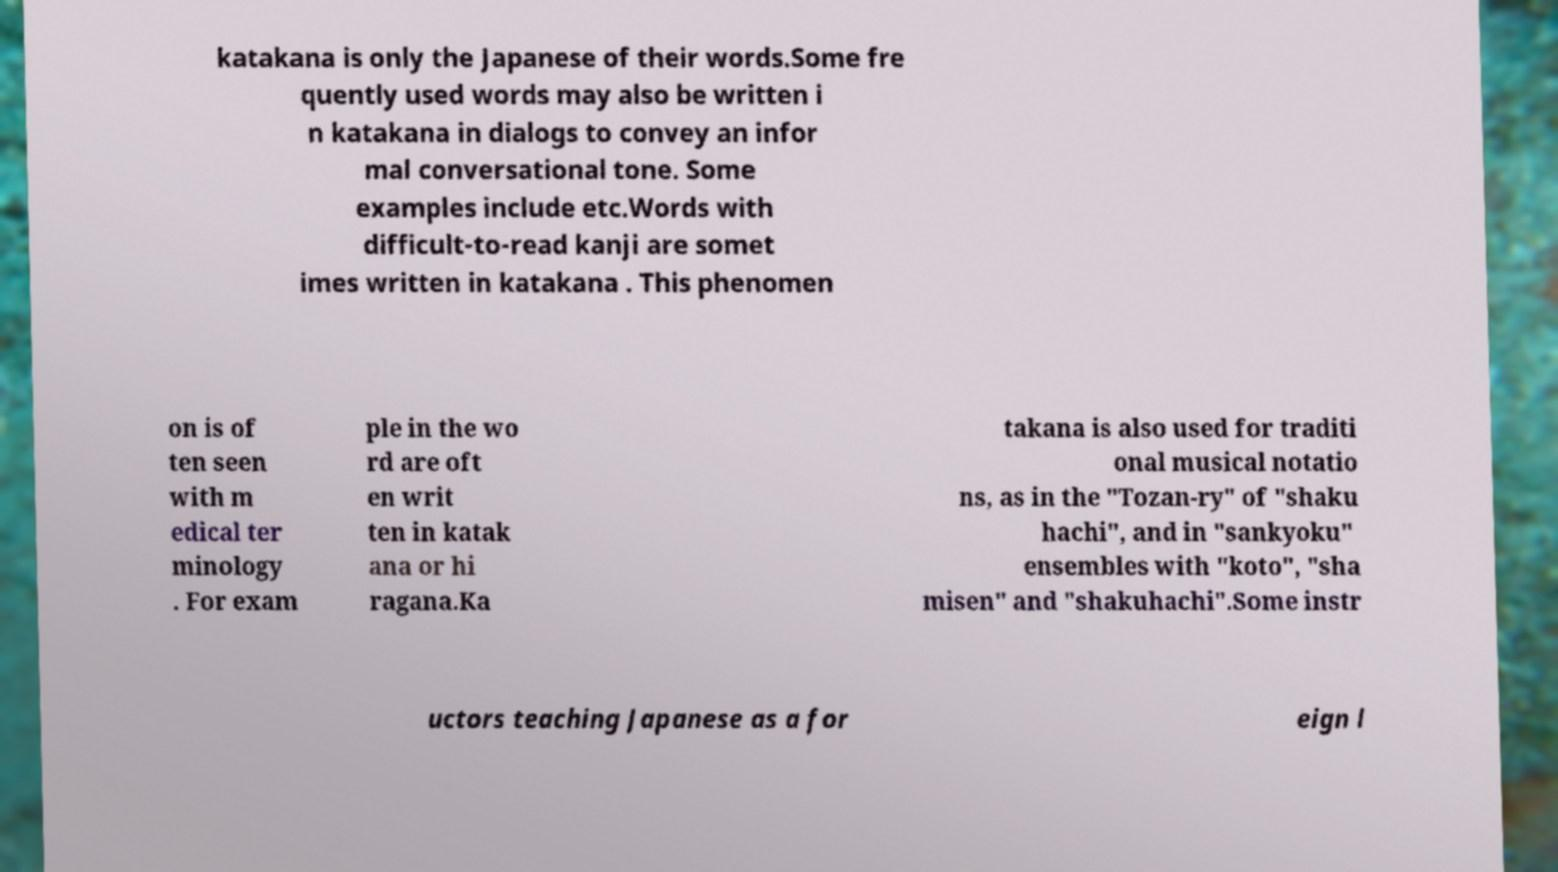Can you accurately transcribe the text from the provided image for me? katakana is only the Japanese of their words.Some fre quently used words may also be written i n katakana in dialogs to convey an infor mal conversational tone. Some examples include etc.Words with difficult-to-read kanji are somet imes written in katakana . This phenomen on is of ten seen with m edical ter minology . For exam ple in the wo rd are oft en writ ten in katak ana or hi ragana.Ka takana is also used for traditi onal musical notatio ns, as in the "Tozan-ry" of "shaku hachi", and in "sankyoku" ensembles with "koto", "sha misen" and "shakuhachi".Some instr uctors teaching Japanese as a for eign l 